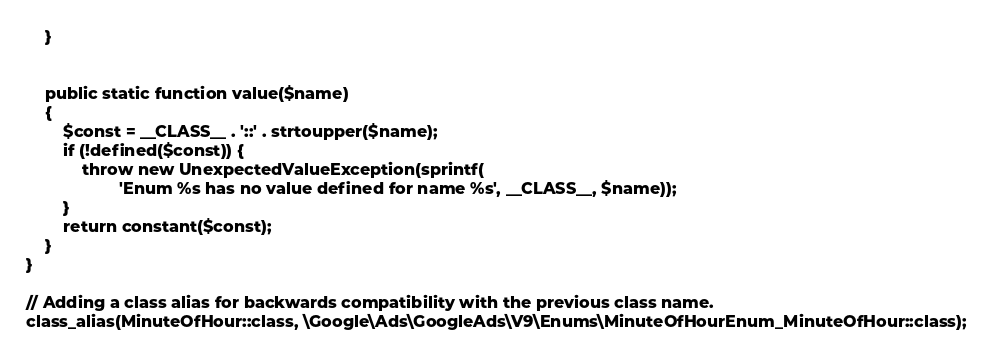<code> <loc_0><loc_0><loc_500><loc_500><_PHP_>    }


    public static function value($name)
    {
        $const = __CLASS__ . '::' . strtoupper($name);
        if (!defined($const)) {
            throw new UnexpectedValueException(sprintf(
                    'Enum %s has no value defined for name %s', __CLASS__, $name));
        }
        return constant($const);
    }
}

// Adding a class alias for backwards compatibility with the previous class name.
class_alias(MinuteOfHour::class, \Google\Ads\GoogleAds\V9\Enums\MinuteOfHourEnum_MinuteOfHour::class);

</code> 